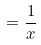Convert formula to latex. <formula><loc_0><loc_0><loc_500><loc_500>= \frac { 1 } { x }</formula> 